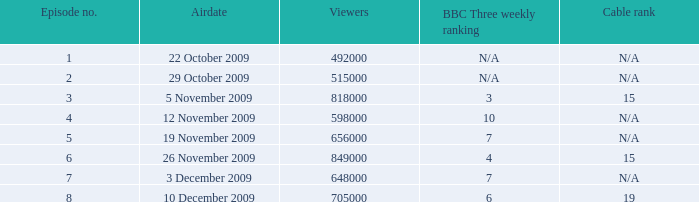How many entries are displayed for viewers when the airdate was 26 november 2009? 1.0. 